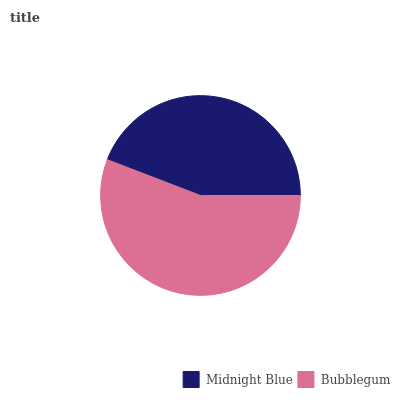Is Midnight Blue the minimum?
Answer yes or no. Yes. Is Bubblegum the maximum?
Answer yes or no. Yes. Is Bubblegum the minimum?
Answer yes or no. No. Is Bubblegum greater than Midnight Blue?
Answer yes or no. Yes. Is Midnight Blue less than Bubblegum?
Answer yes or no. Yes. Is Midnight Blue greater than Bubblegum?
Answer yes or no. No. Is Bubblegum less than Midnight Blue?
Answer yes or no. No. Is Bubblegum the high median?
Answer yes or no. Yes. Is Midnight Blue the low median?
Answer yes or no. Yes. Is Midnight Blue the high median?
Answer yes or no. No. Is Bubblegum the low median?
Answer yes or no. No. 